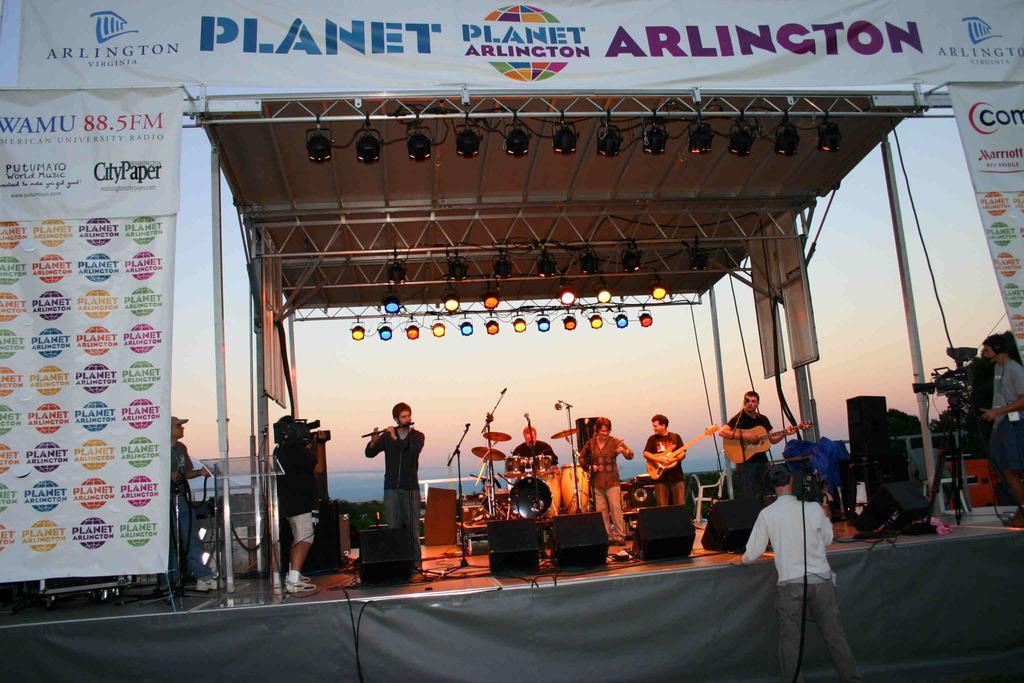Can you describe this image briefly? In this picture I can see many peoples who are standing on the stage and some persons are playing guitar, drum and flute. On the left there is a cameraman who is holding a camera. In front of them I can see the mic and speakers. On the right there is a camera man who is standing near to the camera and banner. In the background I can see the sky. At the bottom I can see some cables. On the left I can see the banner and posters. 